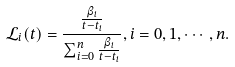<formula> <loc_0><loc_0><loc_500><loc_500>\mathcal { L } _ { i } ( t ) = \frac { \frac { \beta _ { i } } { t - t _ { i } } } { \sum _ { i = 0 } ^ { n } \frac { \beta _ { i } } { t - t _ { i } } } , i = 0 , 1 , \cdots , n .</formula> 